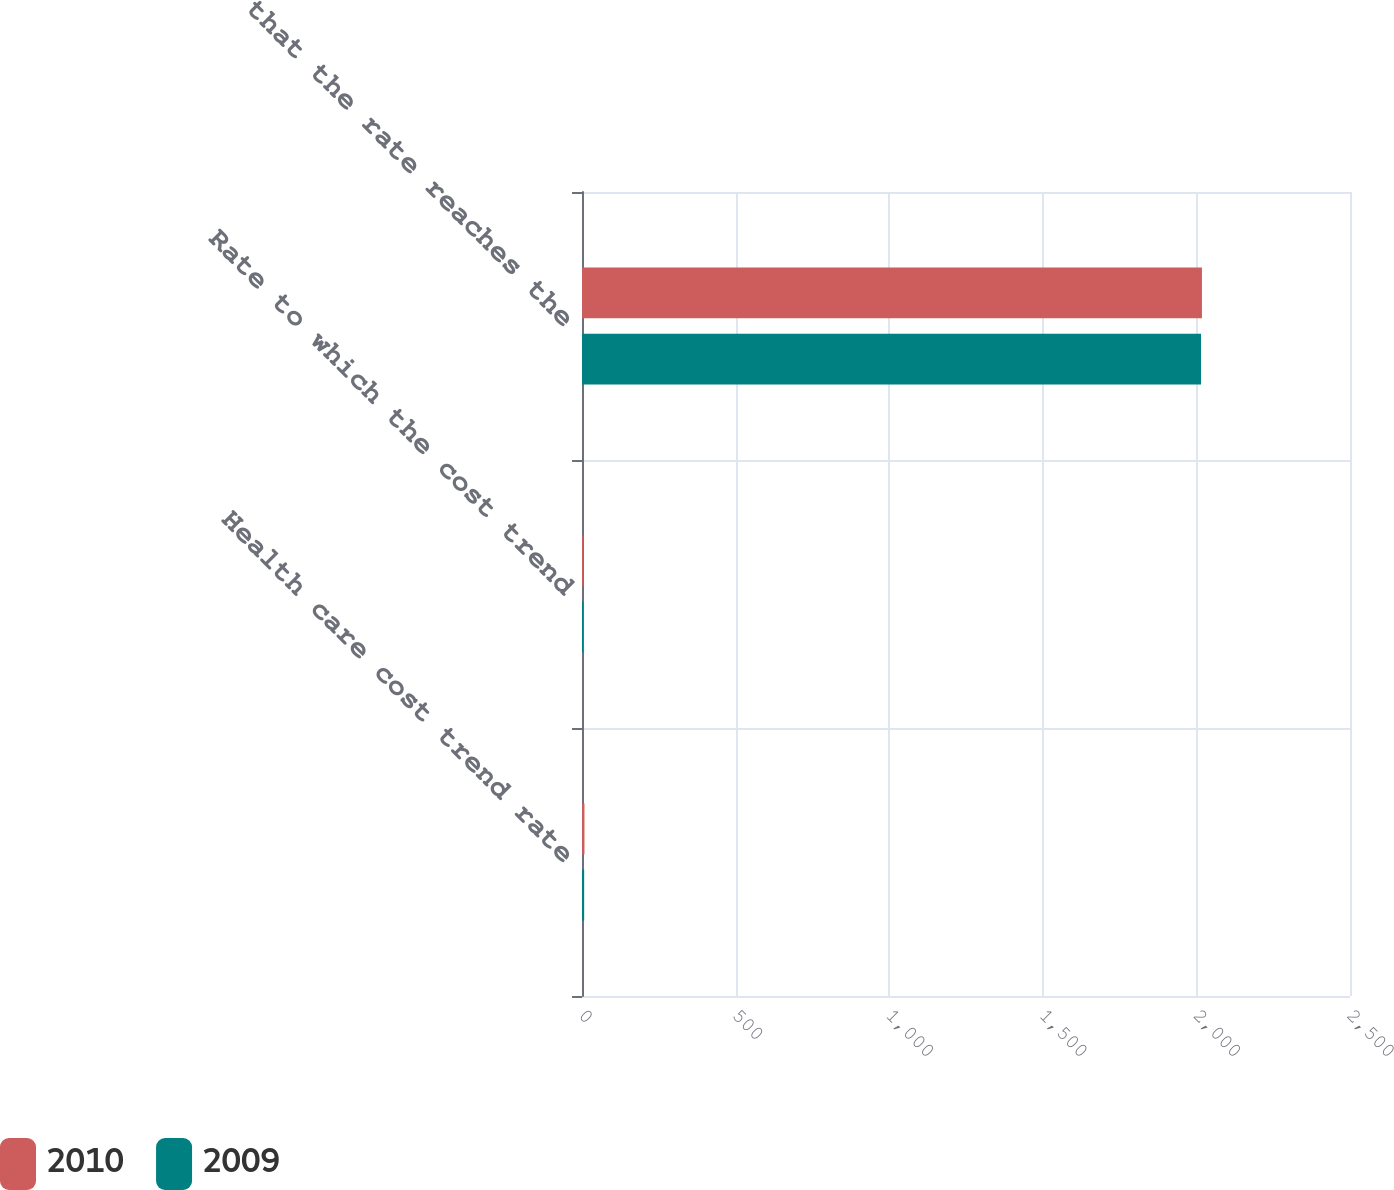<chart> <loc_0><loc_0><loc_500><loc_500><stacked_bar_chart><ecel><fcel>Health care cost trend rate<fcel>Rate to which the cost trend<fcel>Year that the rate reaches the<nl><fcel>2010<fcel>8<fcel>4.5<fcel>2018<nl><fcel>2009<fcel>7<fcel>4.5<fcel>2015<nl></chart> 